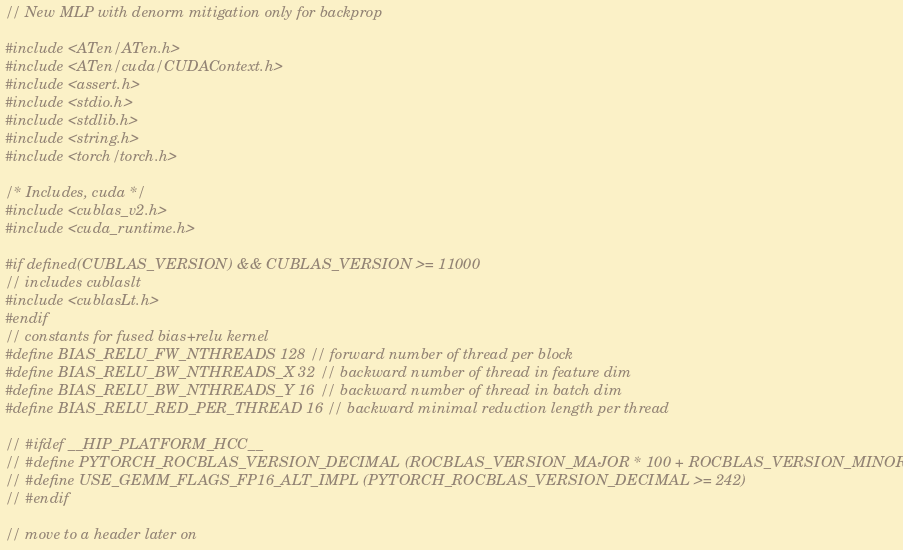Convert code to text. <code><loc_0><loc_0><loc_500><loc_500><_Cuda_>// New MLP with denorm mitigation only for backprop

#include <ATen/ATen.h>
#include <ATen/cuda/CUDAContext.h>
#include <assert.h>
#include <stdio.h>
#include <stdlib.h>
#include <string.h>
#include <torch/torch.h>

/* Includes, cuda */
#include <cublas_v2.h>
#include <cuda_runtime.h>

#if defined(CUBLAS_VERSION) && CUBLAS_VERSION >= 11000
// includes cublaslt
#include <cublasLt.h>
#endif
// constants for fused bias+relu kernel
#define BIAS_RELU_FW_NTHREADS 128 // forward number of thread per block
#define BIAS_RELU_BW_NTHREADS_X 32 // backward number of thread in feature dim
#define BIAS_RELU_BW_NTHREADS_Y 16 // backward number of thread in batch dim
#define BIAS_RELU_RED_PER_THREAD 16 // backward minimal reduction length per thread

// #ifdef __HIP_PLATFORM_HCC__
// #define PYTORCH_ROCBLAS_VERSION_DECIMAL (ROCBLAS_VERSION_MAJOR * 100 + ROCBLAS_VERSION_MINOR)
// #define USE_GEMM_FLAGS_FP16_ALT_IMPL (PYTORCH_ROCBLAS_VERSION_DECIMAL >= 242)
// #endif

// move to a header later on</code> 